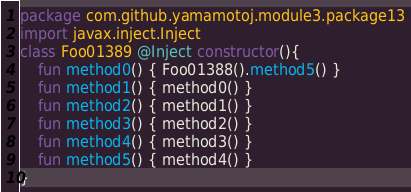Convert code to text. <code><loc_0><loc_0><loc_500><loc_500><_Kotlin_>package com.github.yamamotoj.module3.package13
import javax.inject.Inject
class Foo01389 @Inject constructor(){
    fun method0() { Foo01388().method5() }
    fun method1() { method0() }
    fun method2() { method1() }
    fun method3() { method2() }
    fun method4() { method3() }
    fun method5() { method4() }
}
</code> 